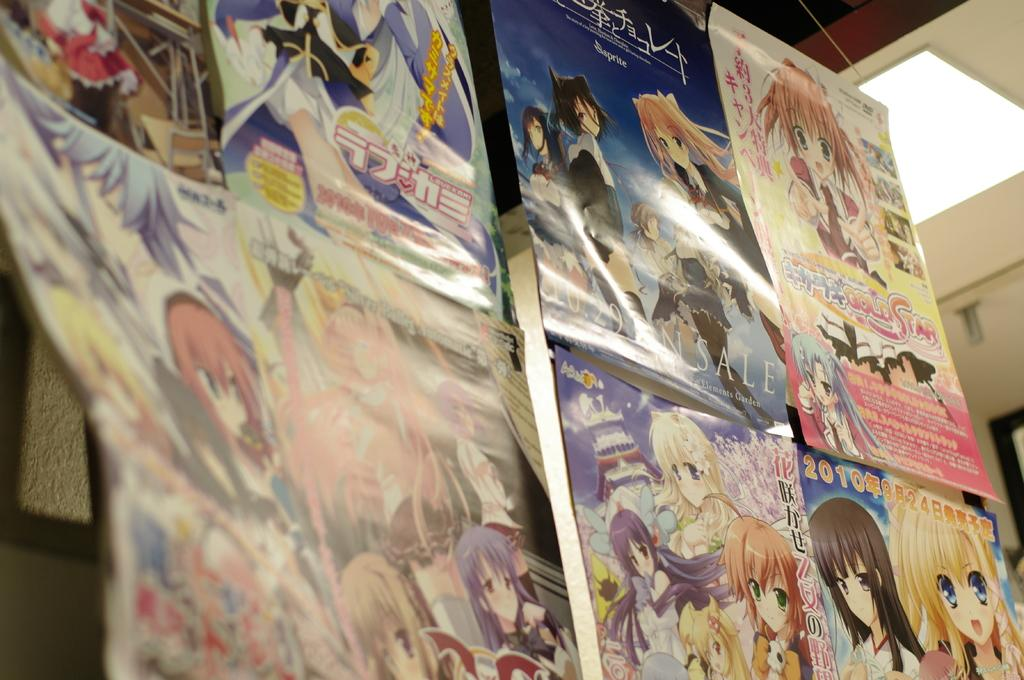<image>
Render a clear and concise summary of the photo. the poster in the bottom right has 2010 on it 